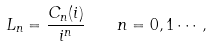<formula> <loc_0><loc_0><loc_500><loc_500>L _ { n } = \frac { C _ { n } ( i ) } { i ^ { n } } \quad n = 0 , 1 \cdots ,</formula> 